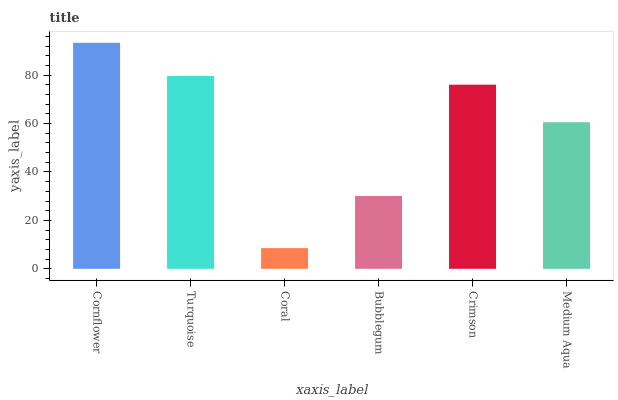Is Coral the minimum?
Answer yes or no. Yes. Is Cornflower the maximum?
Answer yes or no. Yes. Is Turquoise the minimum?
Answer yes or no. No. Is Turquoise the maximum?
Answer yes or no. No. Is Cornflower greater than Turquoise?
Answer yes or no. Yes. Is Turquoise less than Cornflower?
Answer yes or no. Yes. Is Turquoise greater than Cornflower?
Answer yes or no. No. Is Cornflower less than Turquoise?
Answer yes or no. No. Is Crimson the high median?
Answer yes or no. Yes. Is Medium Aqua the low median?
Answer yes or no. Yes. Is Bubblegum the high median?
Answer yes or no. No. Is Cornflower the low median?
Answer yes or no. No. 